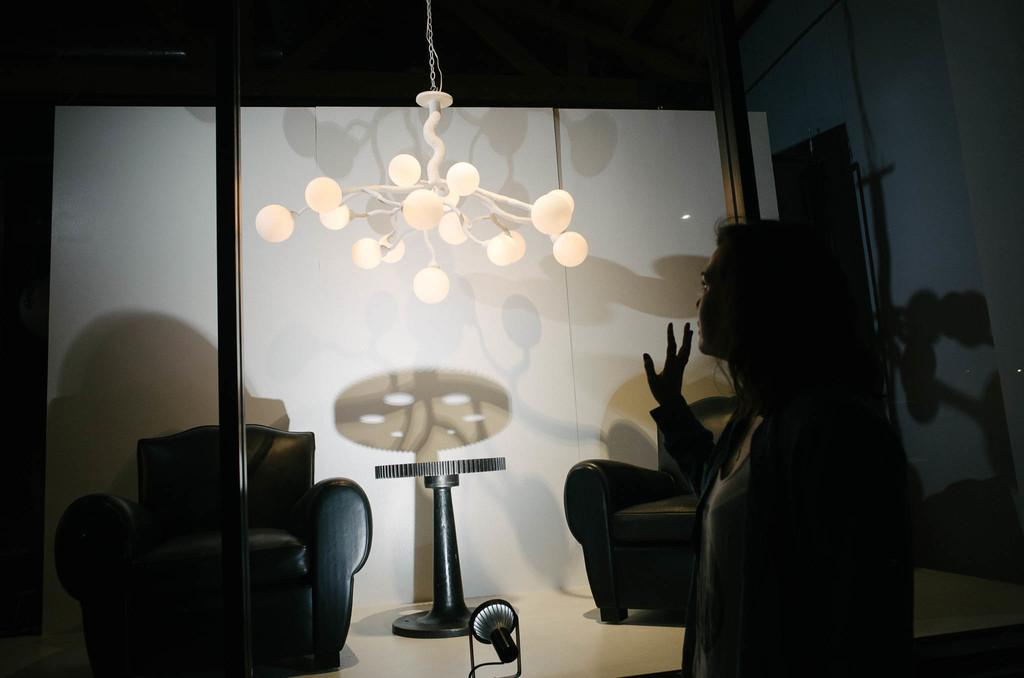Who is the main subject in the image? There is a woman in the image. What is the woman standing in front of? The woman is standing in front of a wall. What furniture is present in front of the wall? There is a sofa and a table in front of the wall. What is the light source on the floor in front of the wall? There is a light on the floor in front of the wall. What type of lighting fixture is hanging from the ceiling? There is a chandelier hanging from the ceiling. How many giants are present in the image? There are no giants present in the image. What type of hair is visible on the woman's head in the image? The image does not show the woman's hair, so it cannot be determined from the image. 